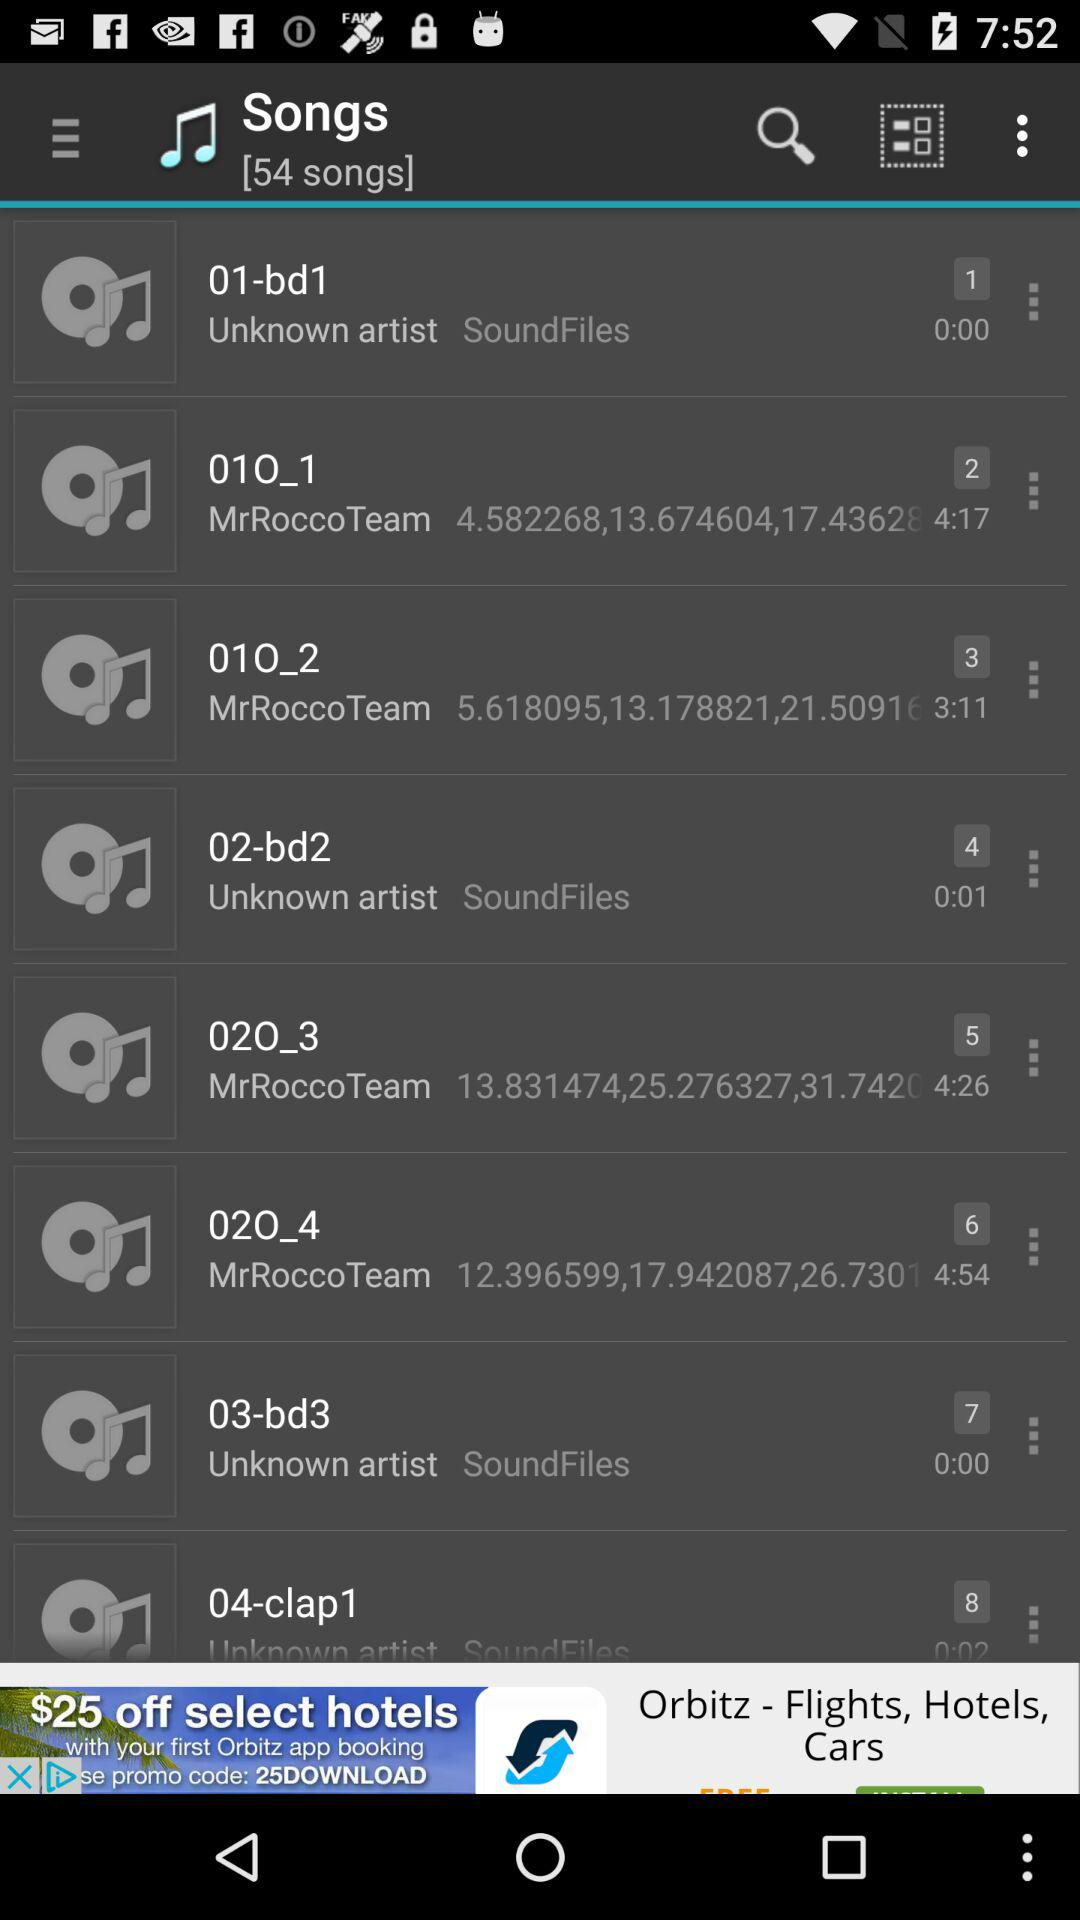What is the duration of "02-bd2"? The duration of "02-bd2" is 1 second. 